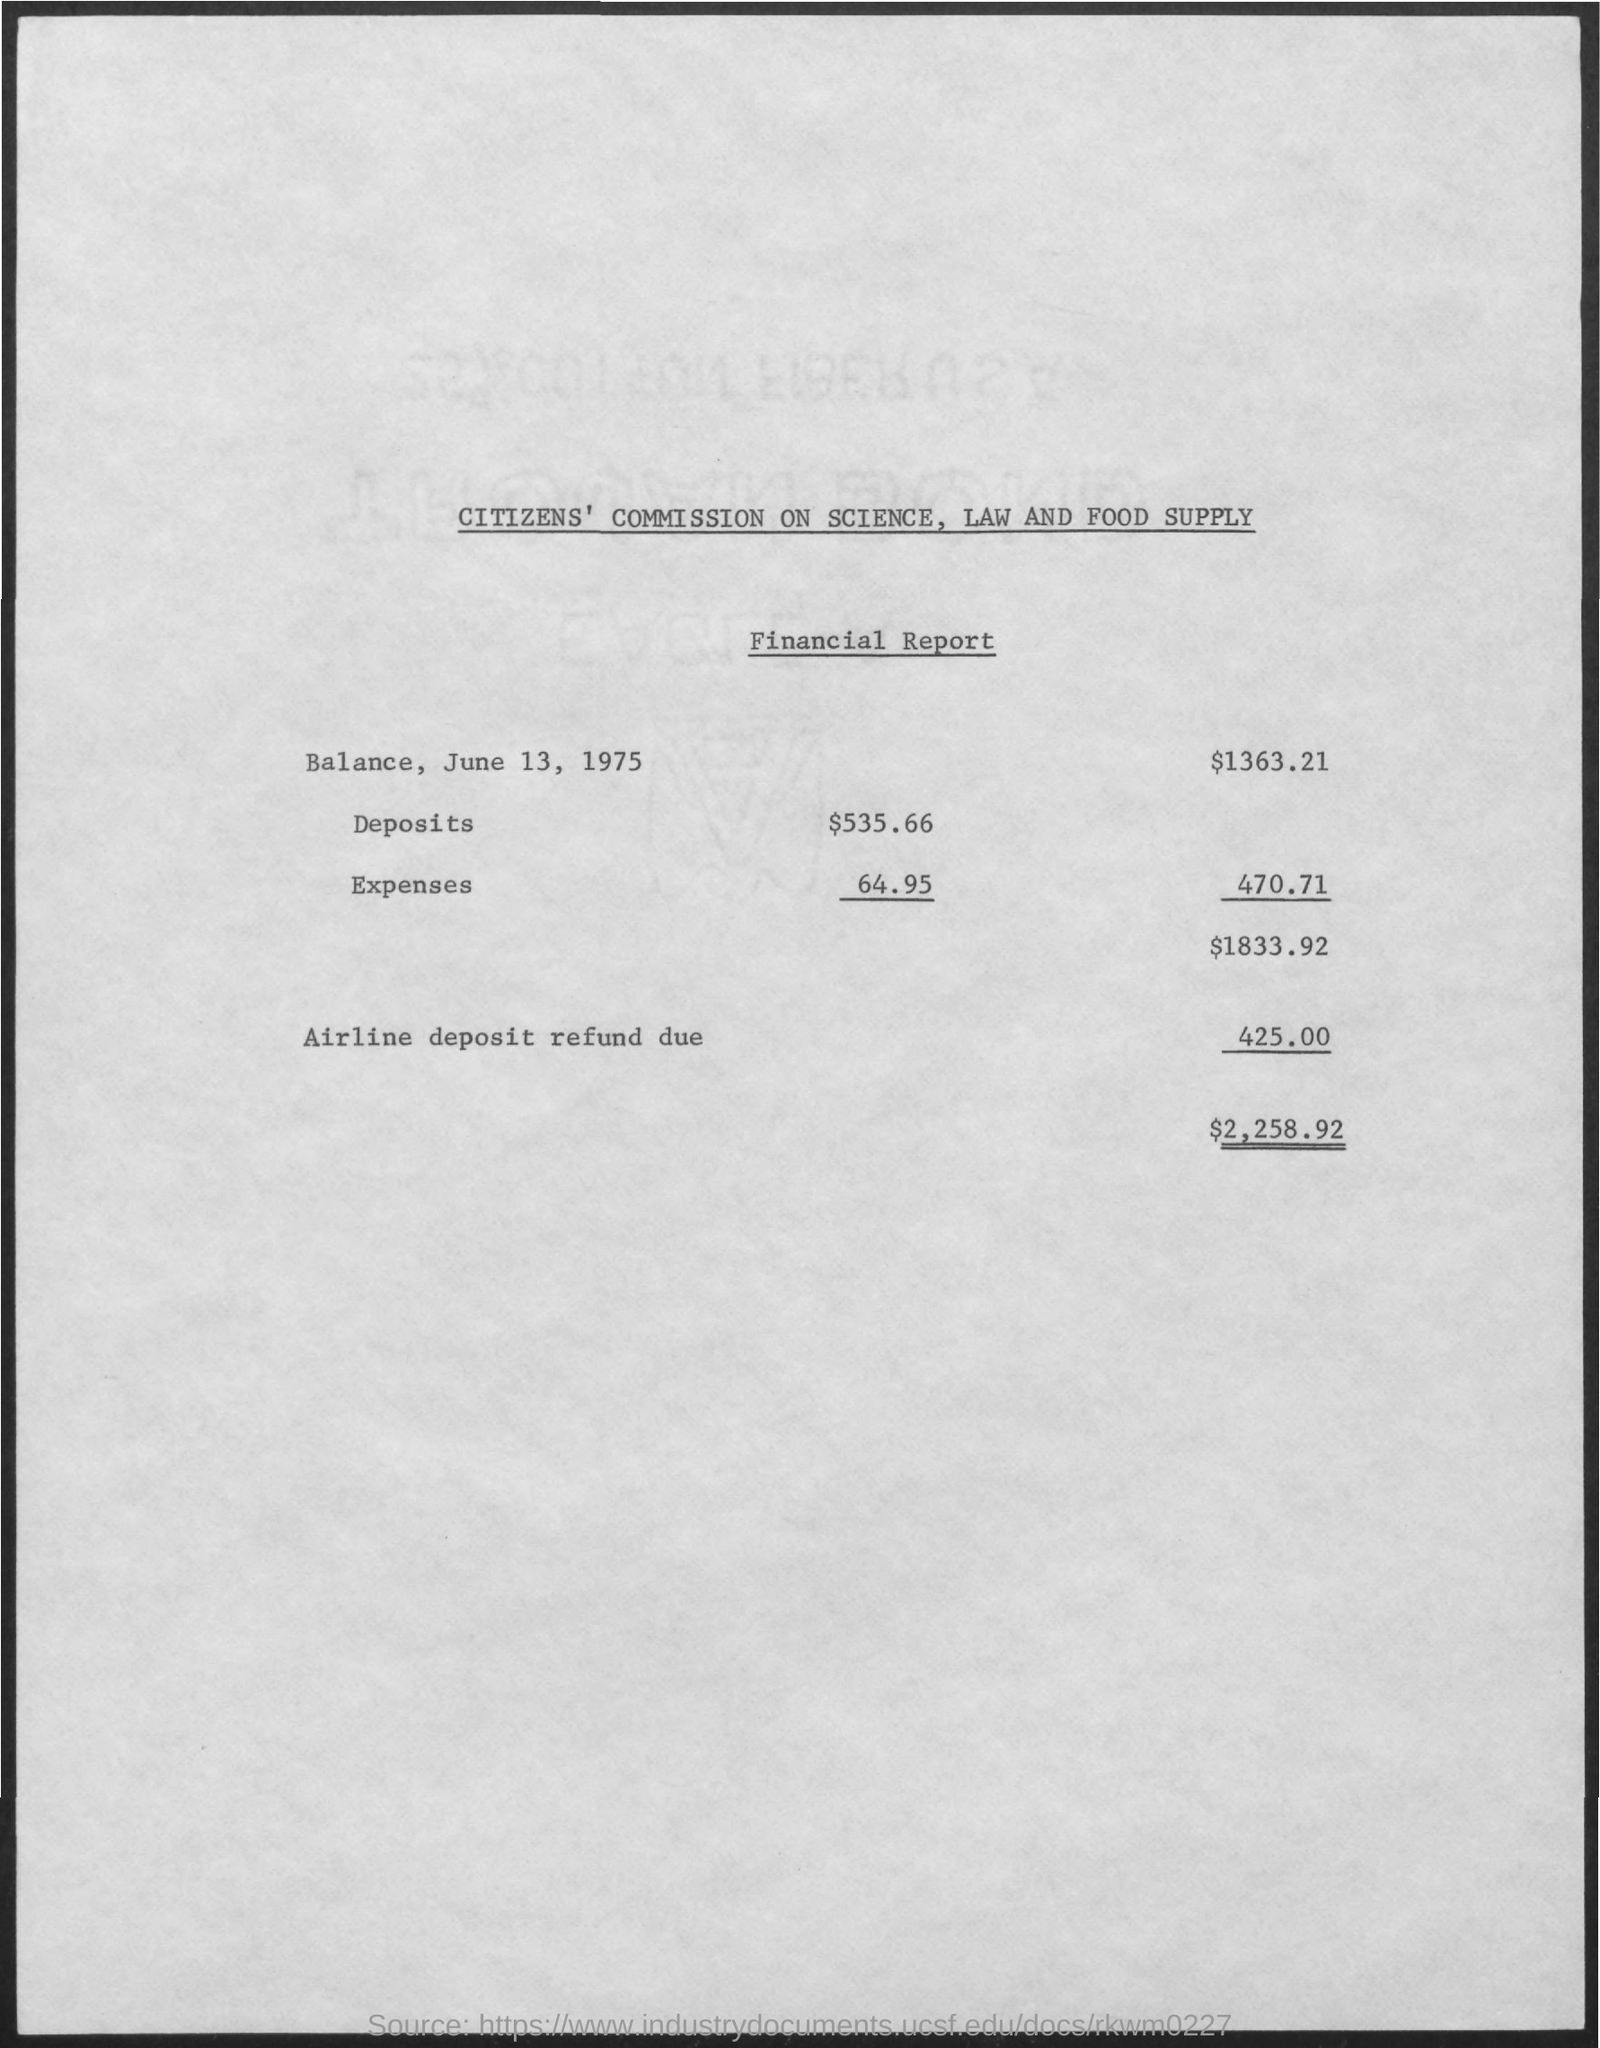Point out several critical features in this image. The value of 'Balance, June 13, 1975' is $1363.21. The value of 'Deposits' is $535.66. 